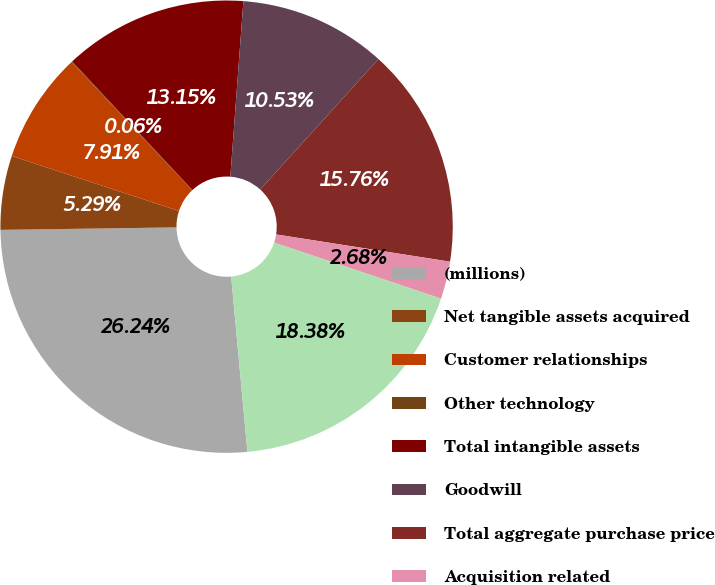Convert chart. <chart><loc_0><loc_0><loc_500><loc_500><pie_chart><fcel>(millions)<fcel>Net tangible assets acquired<fcel>Customer relationships<fcel>Other technology<fcel>Total intangible assets<fcel>Goodwill<fcel>Total aggregate purchase price<fcel>Acquisition related<fcel>Net cash paid for acquisitions<nl><fcel>26.24%<fcel>5.29%<fcel>7.91%<fcel>0.06%<fcel>13.15%<fcel>10.53%<fcel>15.76%<fcel>2.68%<fcel>18.38%<nl></chart> 